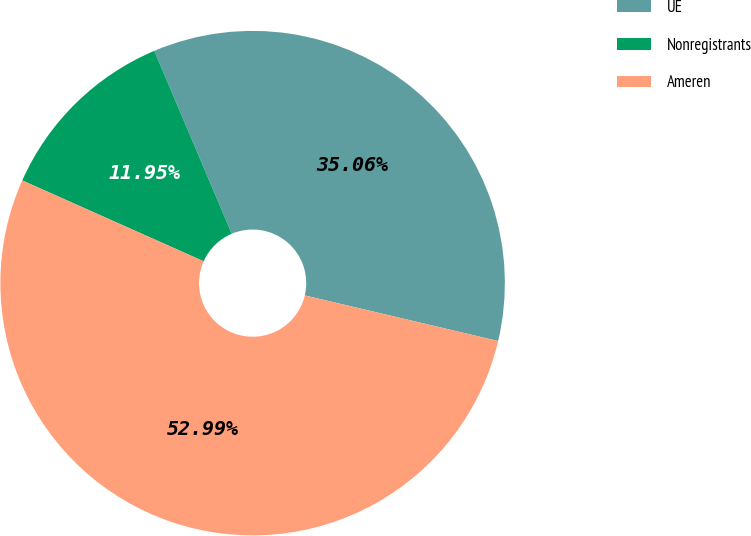Convert chart to OTSL. <chart><loc_0><loc_0><loc_500><loc_500><pie_chart><fcel>UE<fcel>Nonregistrants<fcel>Ameren<nl><fcel>35.06%<fcel>11.95%<fcel>52.99%<nl></chart> 